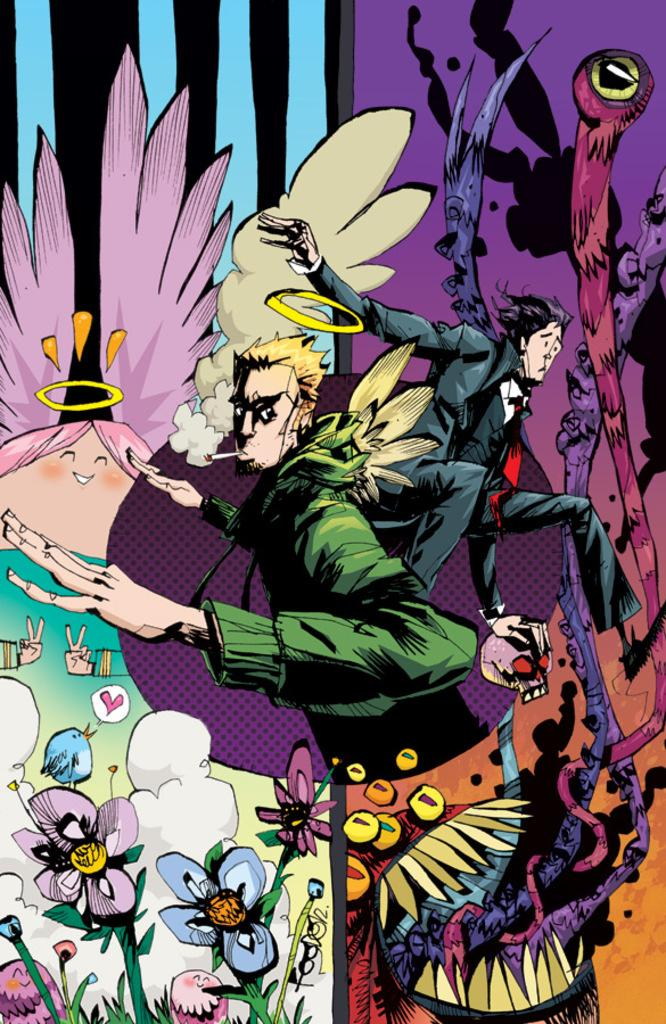What style is the image in? The image is a cartoon. How many people are present in the image? There are two persons in the image. What type of flora can be seen in the image? There are flowers in the image. What other living beings are present in the image? There are animals in the image. What type of flag is being waved by the giraffe in the image? There is no giraffe present in the image, and therefore no flag being waved by a giraffe. 